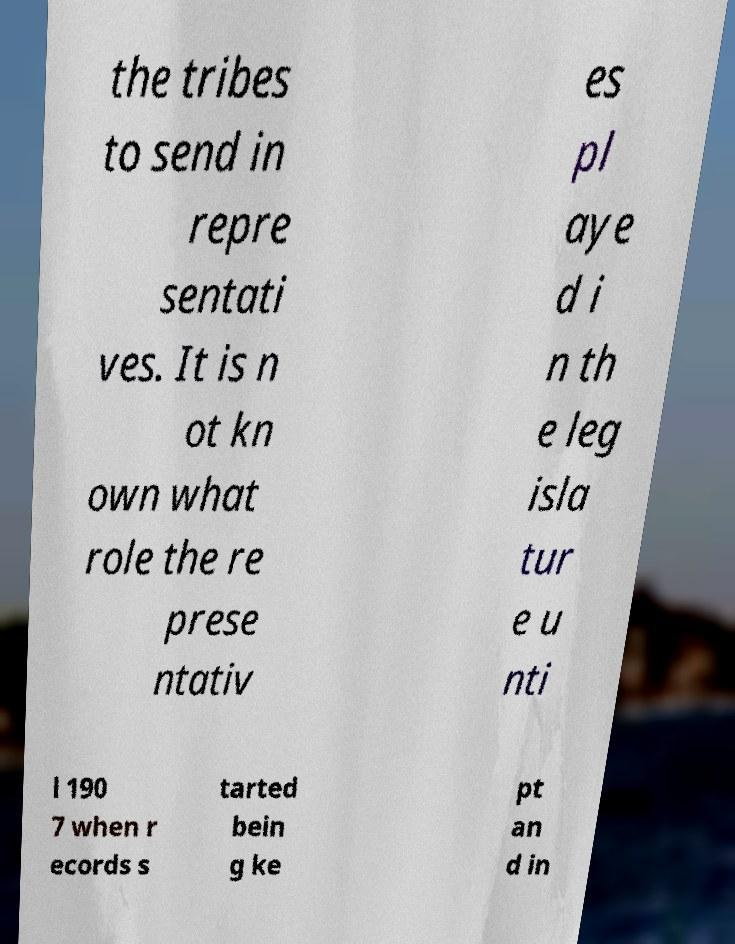Could you assist in decoding the text presented in this image and type it out clearly? the tribes to send in repre sentati ves. It is n ot kn own what role the re prese ntativ es pl aye d i n th e leg isla tur e u nti l 190 7 when r ecords s tarted bein g ke pt an d in 